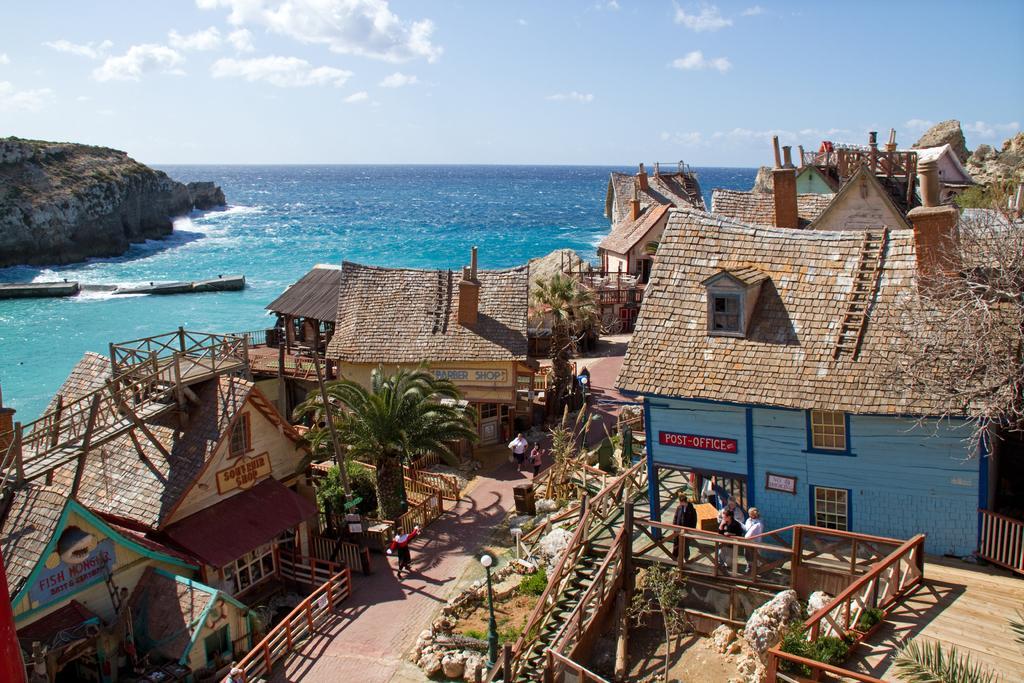Can you describe this image briefly? In this image I can see few houses, they are in cream, blue and brown color. I can also see few plants in green color, few persons walking, background I can see the water in blue color, and the sky is in white color. 